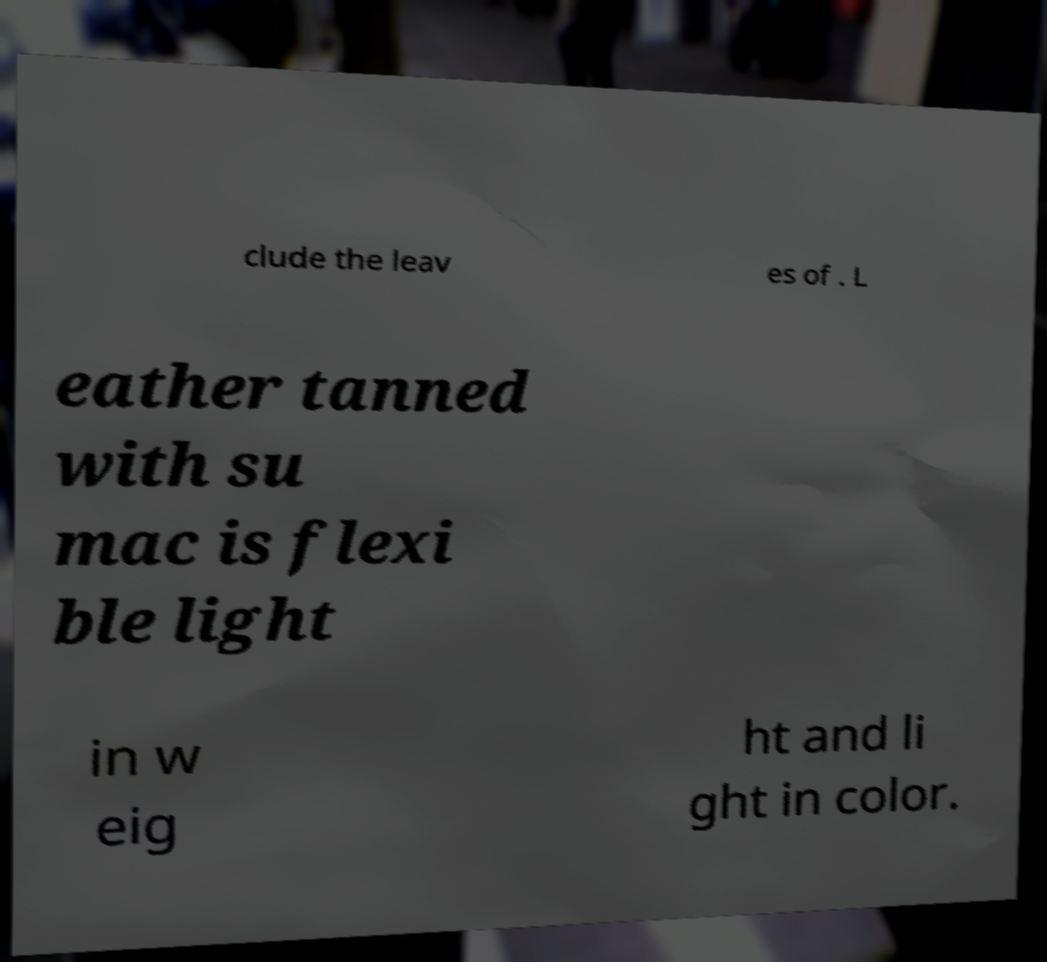Could you extract and type out the text from this image? clude the leav es of . L eather tanned with su mac is flexi ble light in w eig ht and li ght in color. 